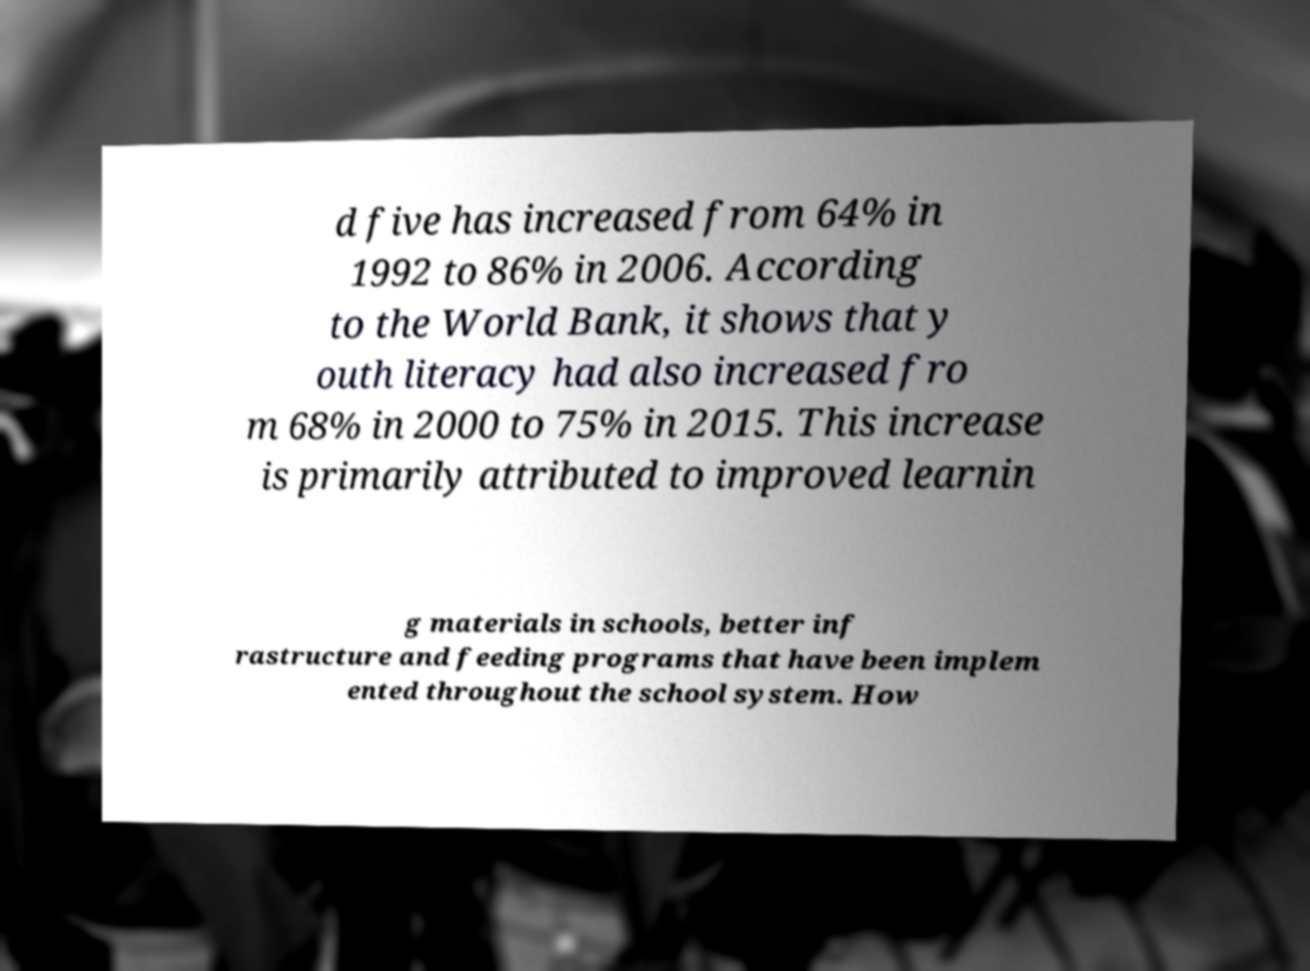Please read and relay the text visible in this image. What does it say? d five has increased from 64% in 1992 to 86% in 2006. According to the World Bank, it shows that y outh literacy had also increased fro m 68% in 2000 to 75% in 2015. This increase is primarily attributed to improved learnin g materials in schools, better inf rastructure and feeding programs that have been implem ented throughout the school system. How 